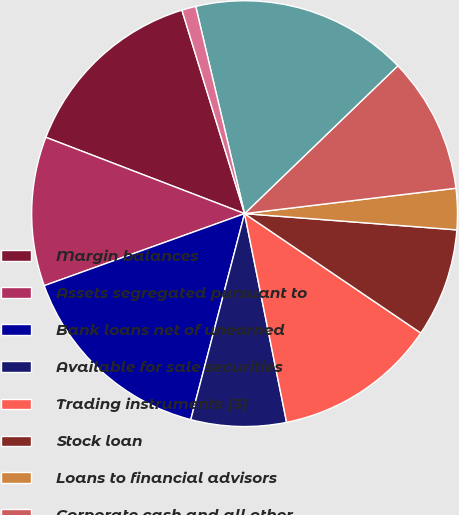Convert chart to OTSL. <chart><loc_0><loc_0><loc_500><loc_500><pie_chart><fcel>Margin balances<fcel>Assets segregated pursuant to<fcel>Bank loans net of unearned<fcel>Available for sale securities<fcel>Trading instruments (3)<fcel>Stock loan<fcel>Loans to financial advisors<fcel>Corporate cash and all other<fcel>Total<fcel>Brokerage client liabilities<nl><fcel>14.41%<fcel>11.33%<fcel>15.44%<fcel>7.23%<fcel>12.36%<fcel>8.26%<fcel>3.12%<fcel>10.31%<fcel>16.47%<fcel>1.07%<nl></chart> 